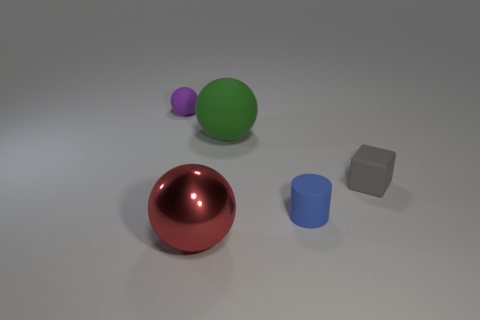There is a thing that is in front of the green ball and behind the tiny cylinder; what size is it?
Make the answer very short. Small. Is the number of gray rubber blocks to the left of the small ball less than the number of large green spheres that are in front of the gray matte thing?
Your answer should be very brief. No. Do the big object that is behind the blue cylinder and the tiny ball behind the green ball have the same material?
Ensure brevity in your answer.  Yes. What shape is the tiny matte thing that is behind the blue matte cylinder and on the right side of the large matte sphere?
Provide a succinct answer. Cube. There is a large object that is left of the rubber ball that is right of the purple object; what is its material?
Your answer should be very brief. Metal. Is the number of tiny matte balls greater than the number of matte balls?
Ensure brevity in your answer.  No. There is a gray thing that is the same size as the blue rubber cylinder; what is its material?
Provide a short and direct response. Rubber. Is the small gray thing made of the same material as the big green thing?
Give a very brief answer. Yes. What number of large purple cylinders have the same material as the large green thing?
Your answer should be compact. 0. How many objects are either rubber objects to the right of the purple rubber object or rubber things that are to the left of the red metallic thing?
Offer a terse response. 4. 